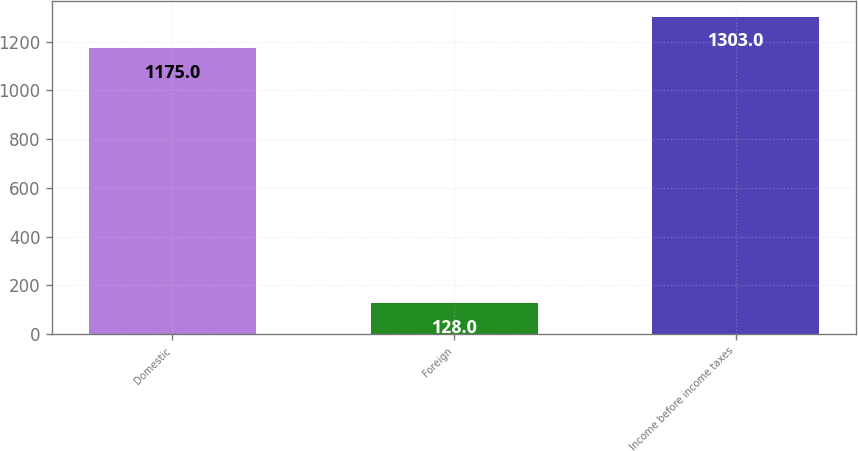Convert chart. <chart><loc_0><loc_0><loc_500><loc_500><bar_chart><fcel>Domestic<fcel>Foreign<fcel>Income before income taxes<nl><fcel>1175<fcel>128<fcel>1303<nl></chart> 